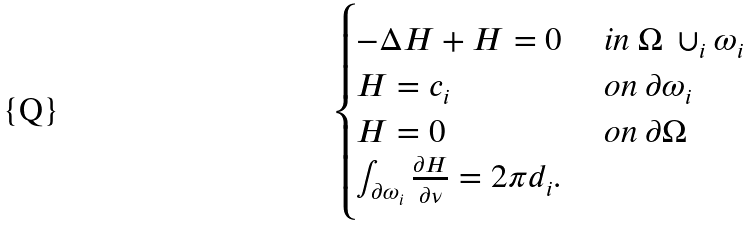<formula> <loc_0><loc_0><loc_500><loc_500>\begin{cases} - \Delta H + H = 0 & \text { in } \Omega \ \cup _ { i } \omega _ { i } \\ H = c _ { i } & \text { on } \partial { \omega _ { i } } \\ H = 0 & \text { on } \partial \Omega \\ \int _ { \partial \omega _ { i } } \frac { \partial H } { \partial \nu } = 2 \pi d _ { i } . \end{cases}</formula> 